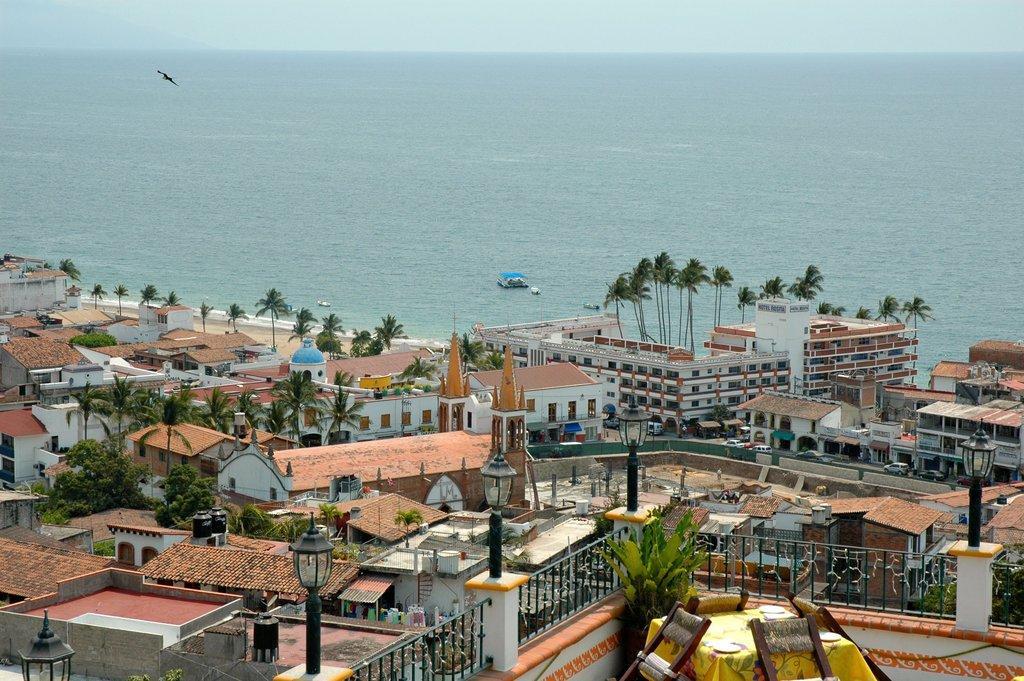In one or two sentences, can you explain what this image depicts? In this image, we can see so many buildings, houses, trees, plants, railings, poles, lights. Background we can see the sea, boats, bird and sky. 